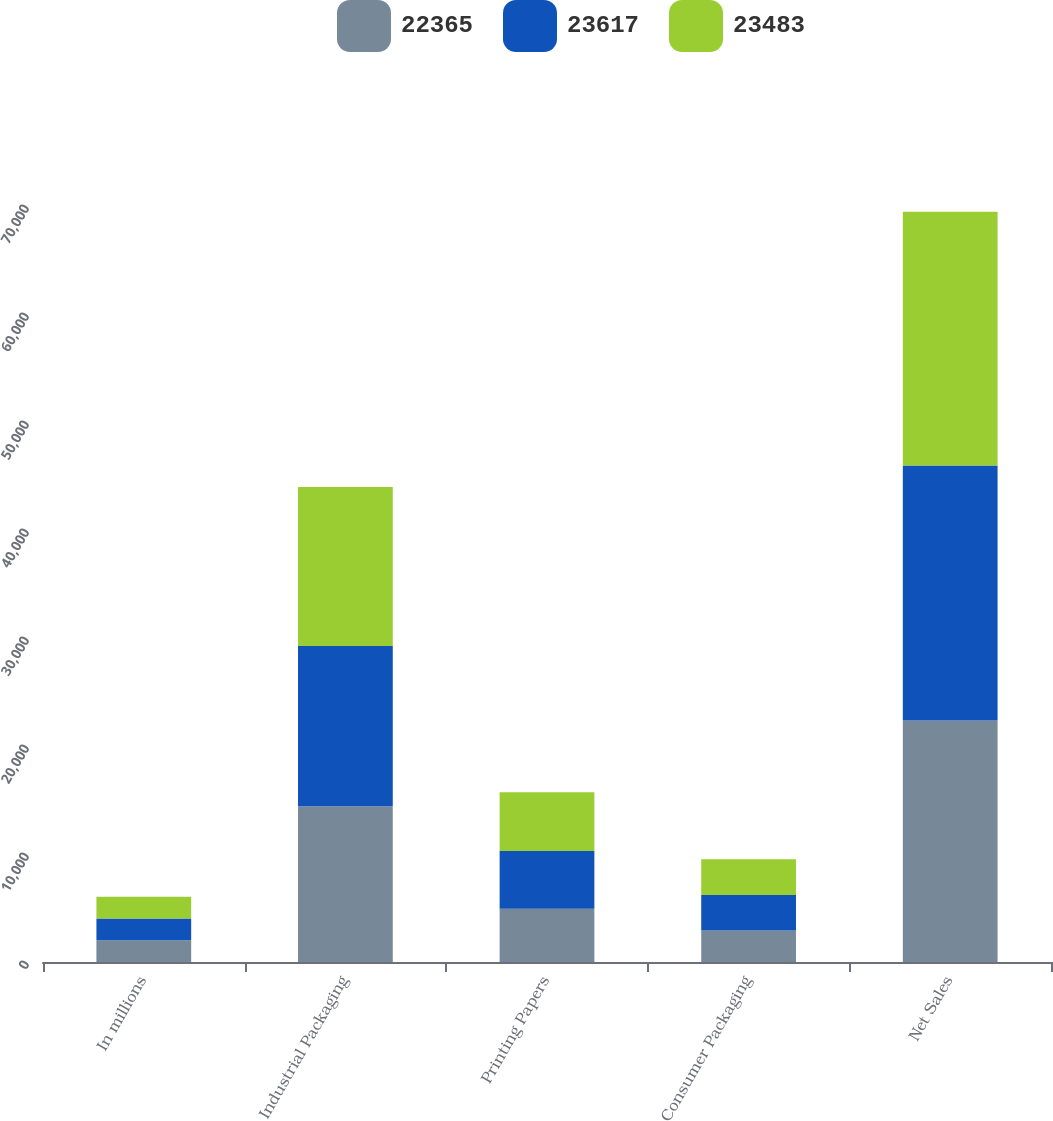Convert chart. <chart><loc_0><loc_0><loc_500><loc_500><stacked_bar_chart><ecel><fcel>In millions<fcel>Industrial Packaging<fcel>Printing Papers<fcel>Consumer Packaging<fcel>Net Sales<nl><fcel>22365<fcel>2015<fcel>14421<fcel>4919<fcel>2907<fcel>22365<nl><fcel>23617<fcel>2014<fcel>14837<fcel>5360<fcel>3307<fcel>23617<nl><fcel>23483<fcel>2013<fcel>14729<fcel>5443<fcel>3311<fcel>23483<nl></chart> 